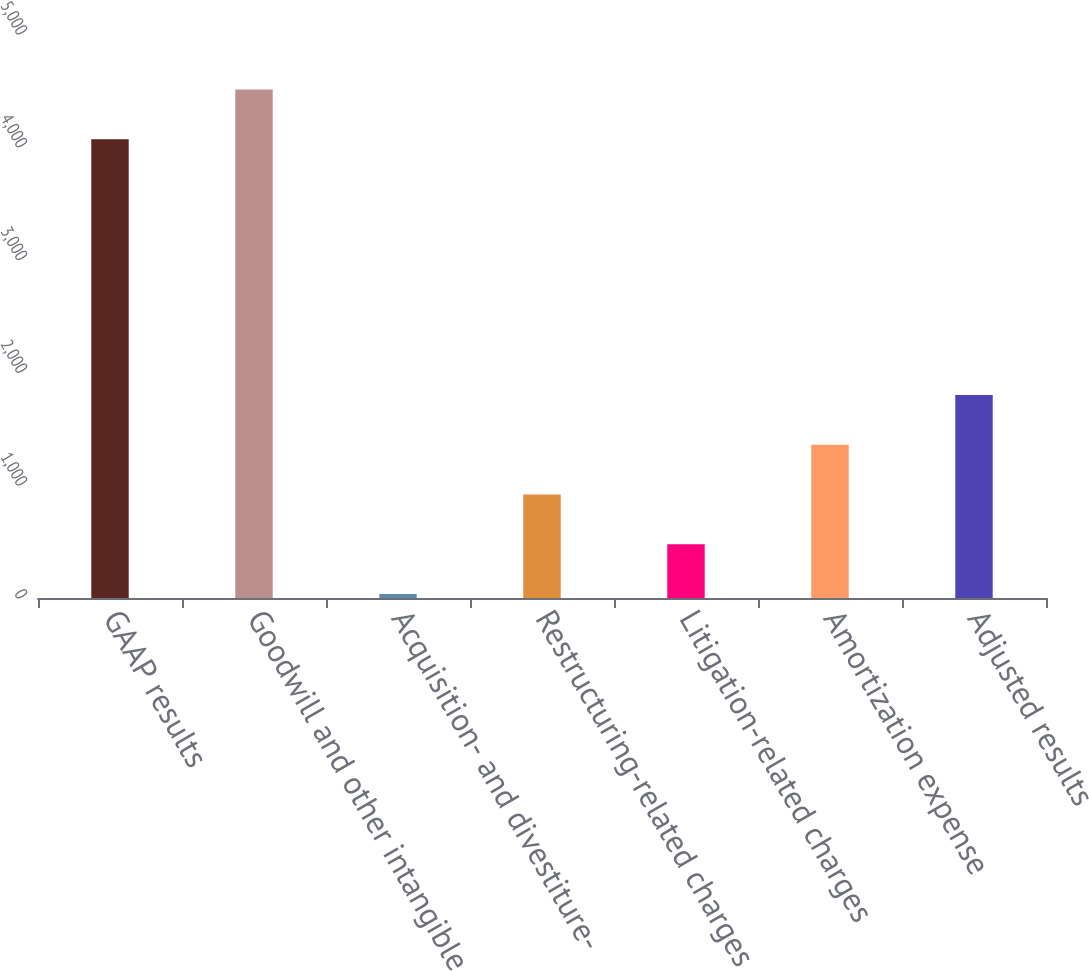<chart> <loc_0><loc_0><loc_500><loc_500><bar_chart><fcel>GAAP results<fcel>Goodwill and other intangible<fcel>Acquisition- and divestiture-<fcel>Restructuring-related charges<fcel>Litigation-related charges<fcel>Amortization expense<fcel>Adjusted results<nl><fcel>4068<fcel>4509<fcel>36<fcel>918<fcel>477<fcel>1359<fcel>1800<nl></chart> 